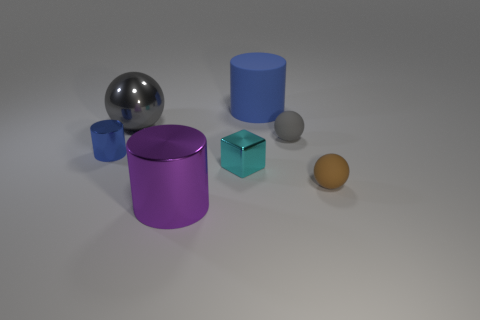Add 1 large blue rubber cylinders. How many objects exist? 8 Subtract all blocks. How many objects are left? 6 Add 4 large things. How many large things exist? 7 Subtract 1 cyan blocks. How many objects are left? 6 Subtract all big purple cylinders. Subtract all big objects. How many objects are left? 3 Add 7 tiny cyan metal things. How many tiny cyan metal things are left? 8 